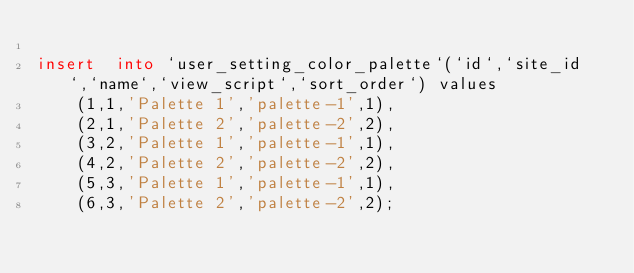<code> <loc_0><loc_0><loc_500><loc_500><_SQL_>
insert  into `user_setting_color_palette`(`id`,`site_id`,`name`,`view_script`,`sort_order`) values
    (1,1,'Palette 1','palette-1',1),
    (2,1,'Palette 2','palette-2',2),
    (3,2,'Palette 1','palette-1',1),
    (4,2,'Palette 2','palette-2',2),
    (5,3,'Palette 1','palette-1',1),
    (6,3,'Palette 2','palette-2',2);
</code> 